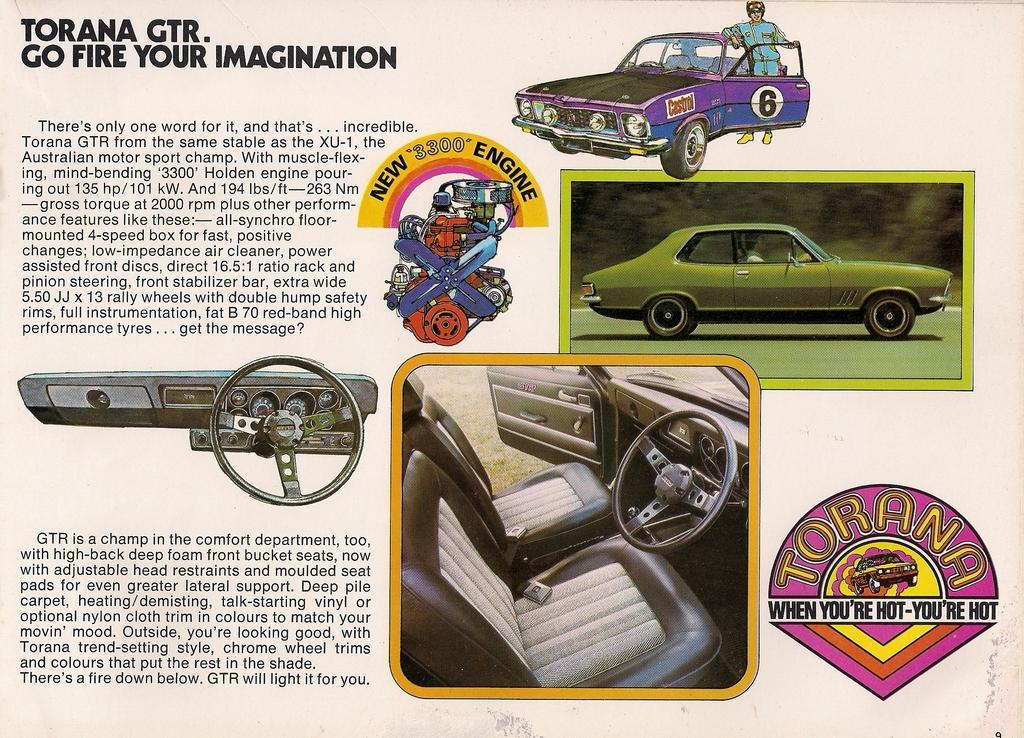What is the main subject of the poster or paper cutting in the image? The poster or paper cutting contains images of a car and its spare parts. What else can be seen on the poster or paper cutting besides the images? There is text on the poster or paper cutting. How many clovers are depicted on the poster or paper cutting? There are no clovers depicted on the poster or paper cutting; it features images of a car and its spare parts. What type of material is used to rub the images onto the poster or paper cutting? The image does not provide information about the materials used to create the poster or paper cutting, so it cannot be determined from the image. 